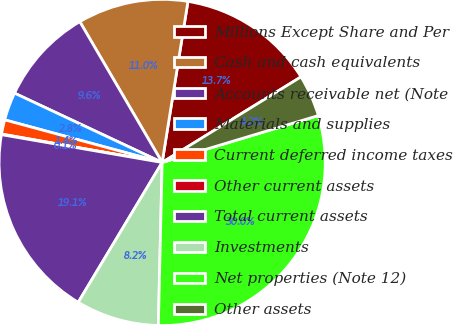Convert chart to OTSL. <chart><loc_0><loc_0><loc_500><loc_500><pie_chart><fcel>Millions Except Share and Per<fcel>Cash and cash equivalents<fcel>Accounts receivable net (Note<fcel>Materials and supplies<fcel>Current deferred income taxes<fcel>Other current assets<fcel>Total current assets<fcel>Investments<fcel>Net properties (Note 12)<fcel>Other assets<nl><fcel>13.68%<fcel>10.95%<fcel>9.59%<fcel>2.78%<fcel>1.42%<fcel>0.06%<fcel>19.12%<fcel>8.23%<fcel>30.01%<fcel>4.15%<nl></chart> 